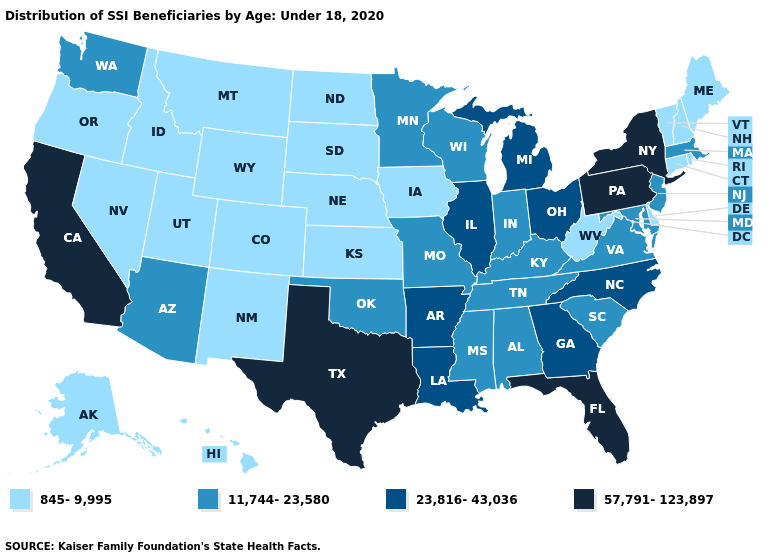What is the value of Maryland?
Give a very brief answer. 11,744-23,580. What is the value of New Hampshire?
Short answer required. 845-9,995. What is the lowest value in the West?
Short answer required. 845-9,995. What is the value of Maine?
Short answer required. 845-9,995. What is the value of Wisconsin?
Give a very brief answer. 11,744-23,580. What is the lowest value in the USA?
Short answer required. 845-9,995. Name the states that have a value in the range 845-9,995?
Write a very short answer. Alaska, Colorado, Connecticut, Delaware, Hawaii, Idaho, Iowa, Kansas, Maine, Montana, Nebraska, Nevada, New Hampshire, New Mexico, North Dakota, Oregon, Rhode Island, South Dakota, Utah, Vermont, West Virginia, Wyoming. Does Oklahoma have a higher value than California?
Write a very short answer. No. What is the value of Minnesota?
Concise answer only. 11,744-23,580. Does Delaware have the lowest value in the South?
Keep it brief. Yes. Name the states that have a value in the range 845-9,995?
Give a very brief answer. Alaska, Colorado, Connecticut, Delaware, Hawaii, Idaho, Iowa, Kansas, Maine, Montana, Nebraska, Nevada, New Hampshire, New Mexico, North Dakota, Oregon, Rhode Island, South Dakota, Utah, Vermont, West Virginia, Wyoming. What is the lowest value in the USA?
Concise answer only. 845-9,995. What is the value of Pennsylvania?
Quick response, please. 57,791-123,897. Does Massachusetts have the highest value in the Northeast?
Answer briefly. No. Does the map have missing data?
Give a very brief answer. No. 